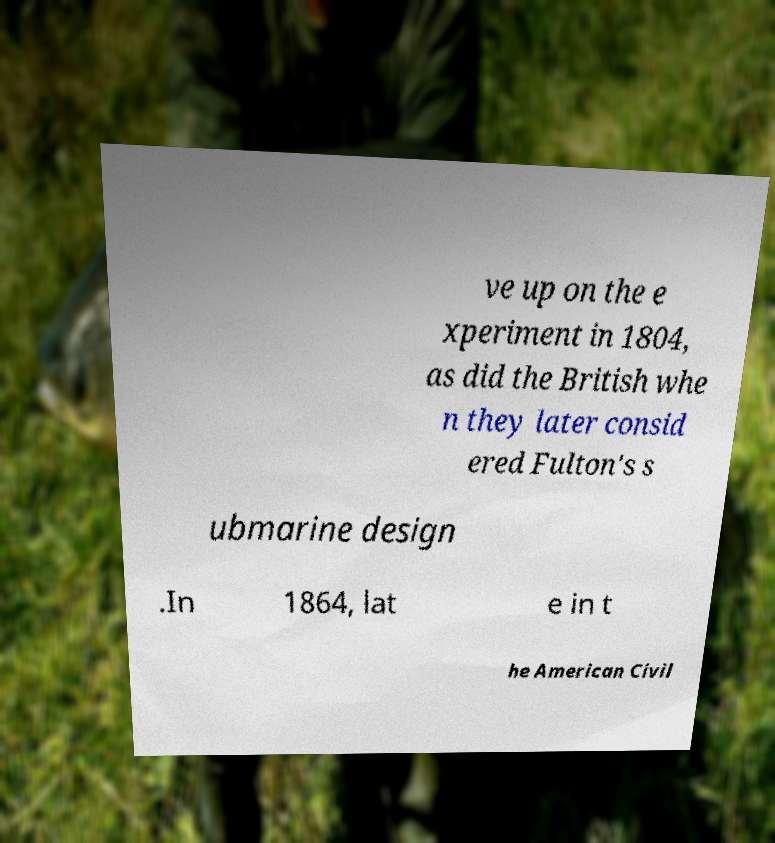What messages or text are displayed in this image? I need them in a readable, typed format. ve up on the e xperiment in 1804, as did the British whe n they later consid ered Fulton's s ubmarine design .In 1864, lat e in t he American Civil 